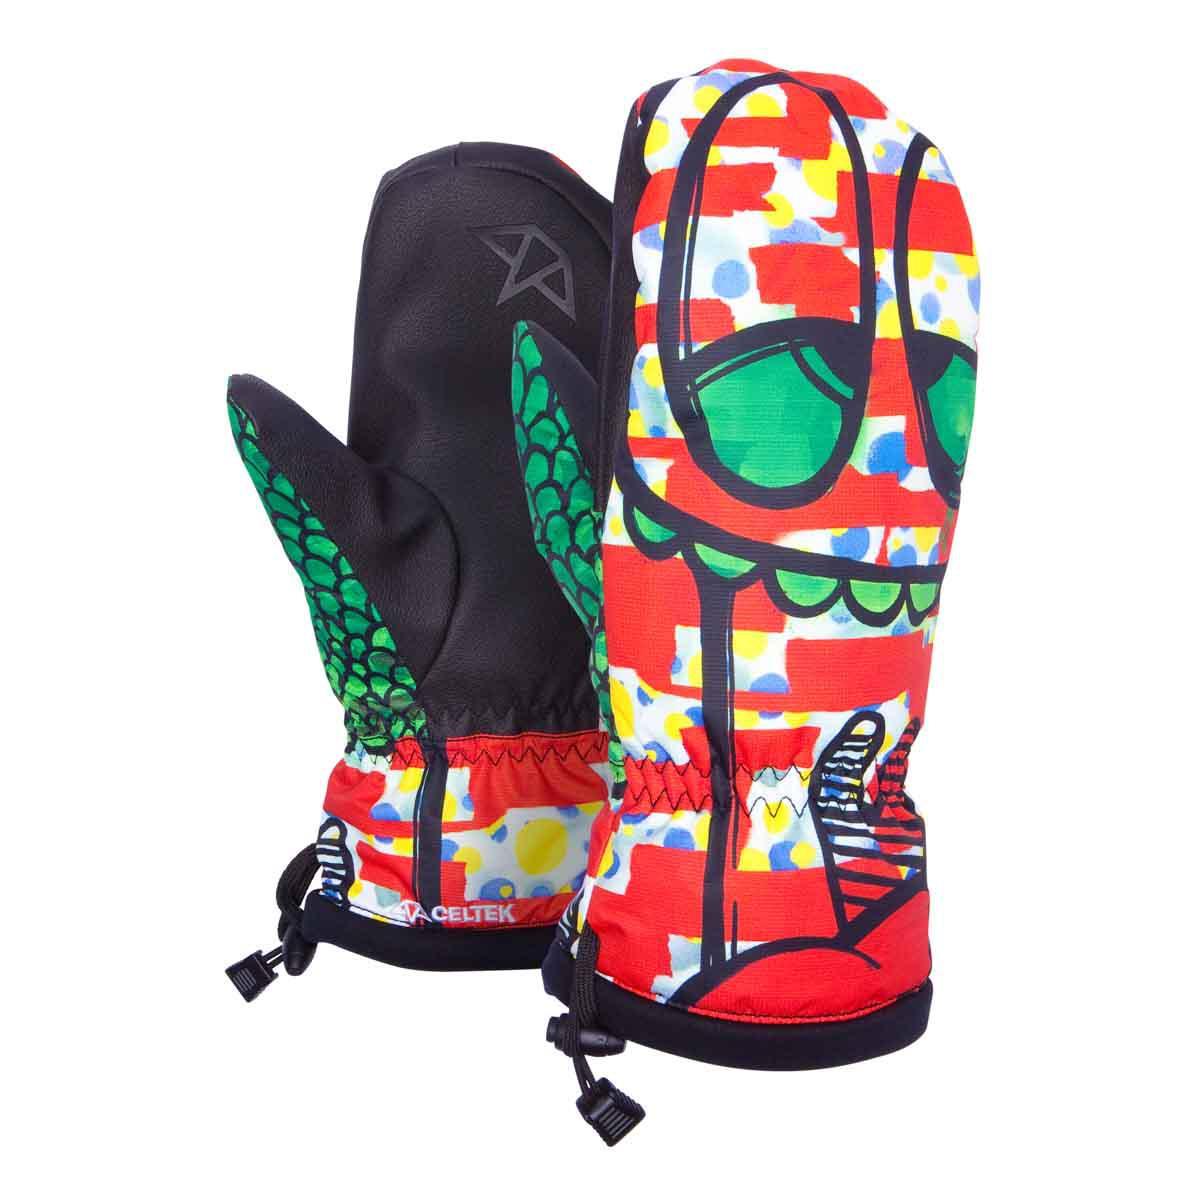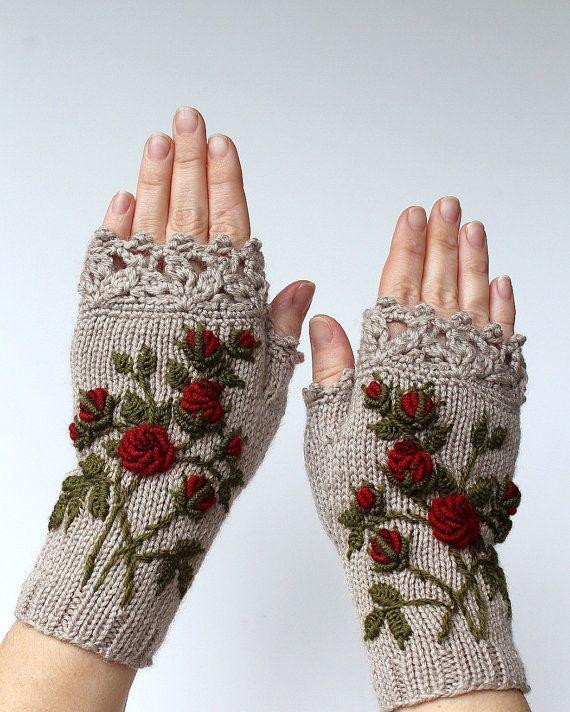The first image is the image on the left, the second image is the image on the right. For the images shown, is this caption "One pair of knit gloves are being worn on someone's hands." true? Answer yes or no. Yes. The first image is the image on the left, the second image is the image on the right. For the images shown, is this caption "No image shows more than one pair of """"mittens"""" or any other wearable item, and at least one mitten pair has gray and dark red colors." true? Answer yes or no. Yes. 